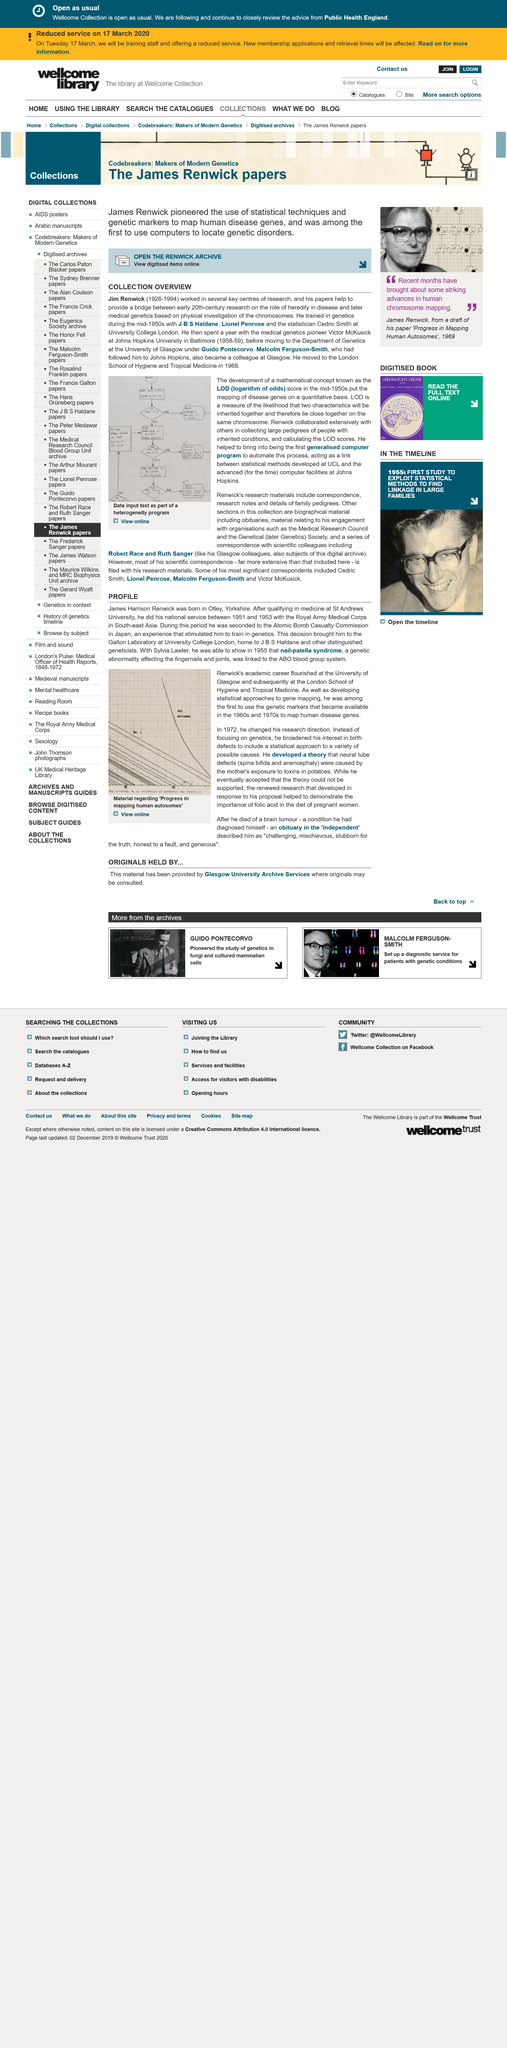List a handful of essential elements in this visual. The Johns Hopkins University is located in the city of Baltimore. James Harrison Renwick was born in Otley, Yorkshire, on a day that will forever be remembered. In 1968, Renwick moved to the School of Hygiene and Tropical Medicine. During the period of 1951 to 1953, James Harrison Renwick served his national service with the Royal Army Medical Corps in Southeast Asia. James Harrison Renwick performed his national service with the Royal Army Medical Corps between 1951 and 1953. 